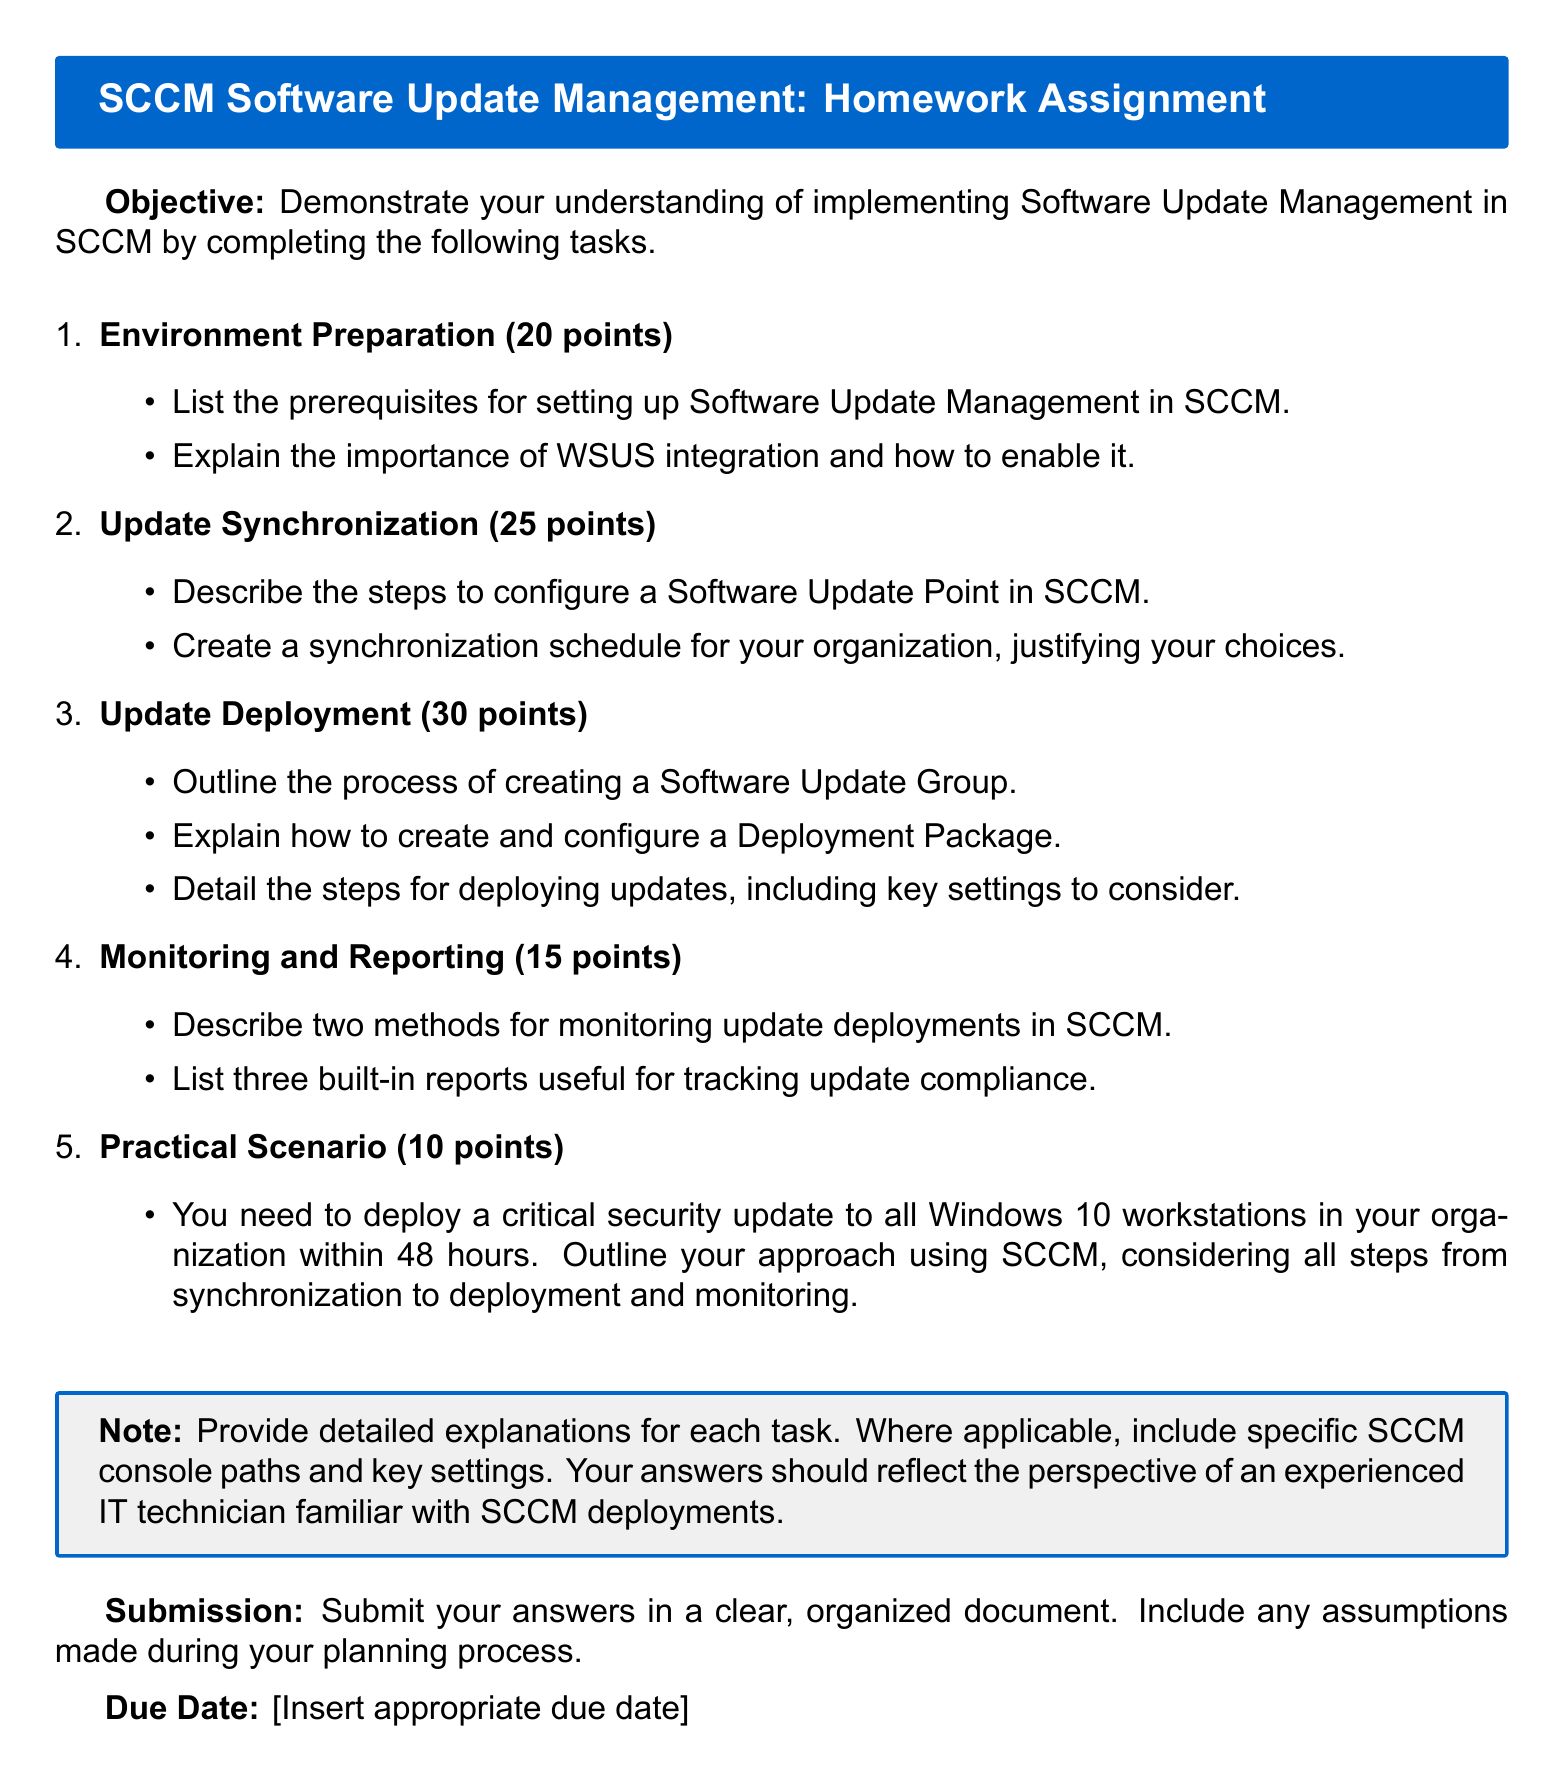What is the total number of points for Environment Preparation? The document states that Environment Preparation is worth 20 points.
Answer: 20 points What are the maximum points for Update Deployment? The section Update Deployment is allotted 30 points as indicated in the document.
Answer: 30 points How is Software Update Management introduced in the document? The introduction specifies the objective of demonstrating understanding in Software Update Management in SCCM.
Answer: Objective What are the two methods for monitoring update deployments mentioned? The document indicates a need to describe methods for monitoring; however, it does not specify the methods directly, requiring reasoning based on knowledge of SCCM.
Answer: N/A How many built-in reports are noted for tracking update compliance? The homework assignment requests listing three built-in reports useful for tracking update compliance.
Answer: Three What is required in the Practical Scenario section? The assignment asks to outline the approach for deploying a critical security update to Windows 10 workstations.
Answer: Outline an approach What type of document is this? This document is categorized as a Homework Assignment for Software Update Management in SCCM.
Answer: Homework Assignment What color is used for the header box in the document? The header box uses the color techblue, as specified in the document formatting.
Answer: techblue What is the due date status in the document? The document includes a placeholder for the due date but does not specify it.
Answer: Insert appropriate due date 